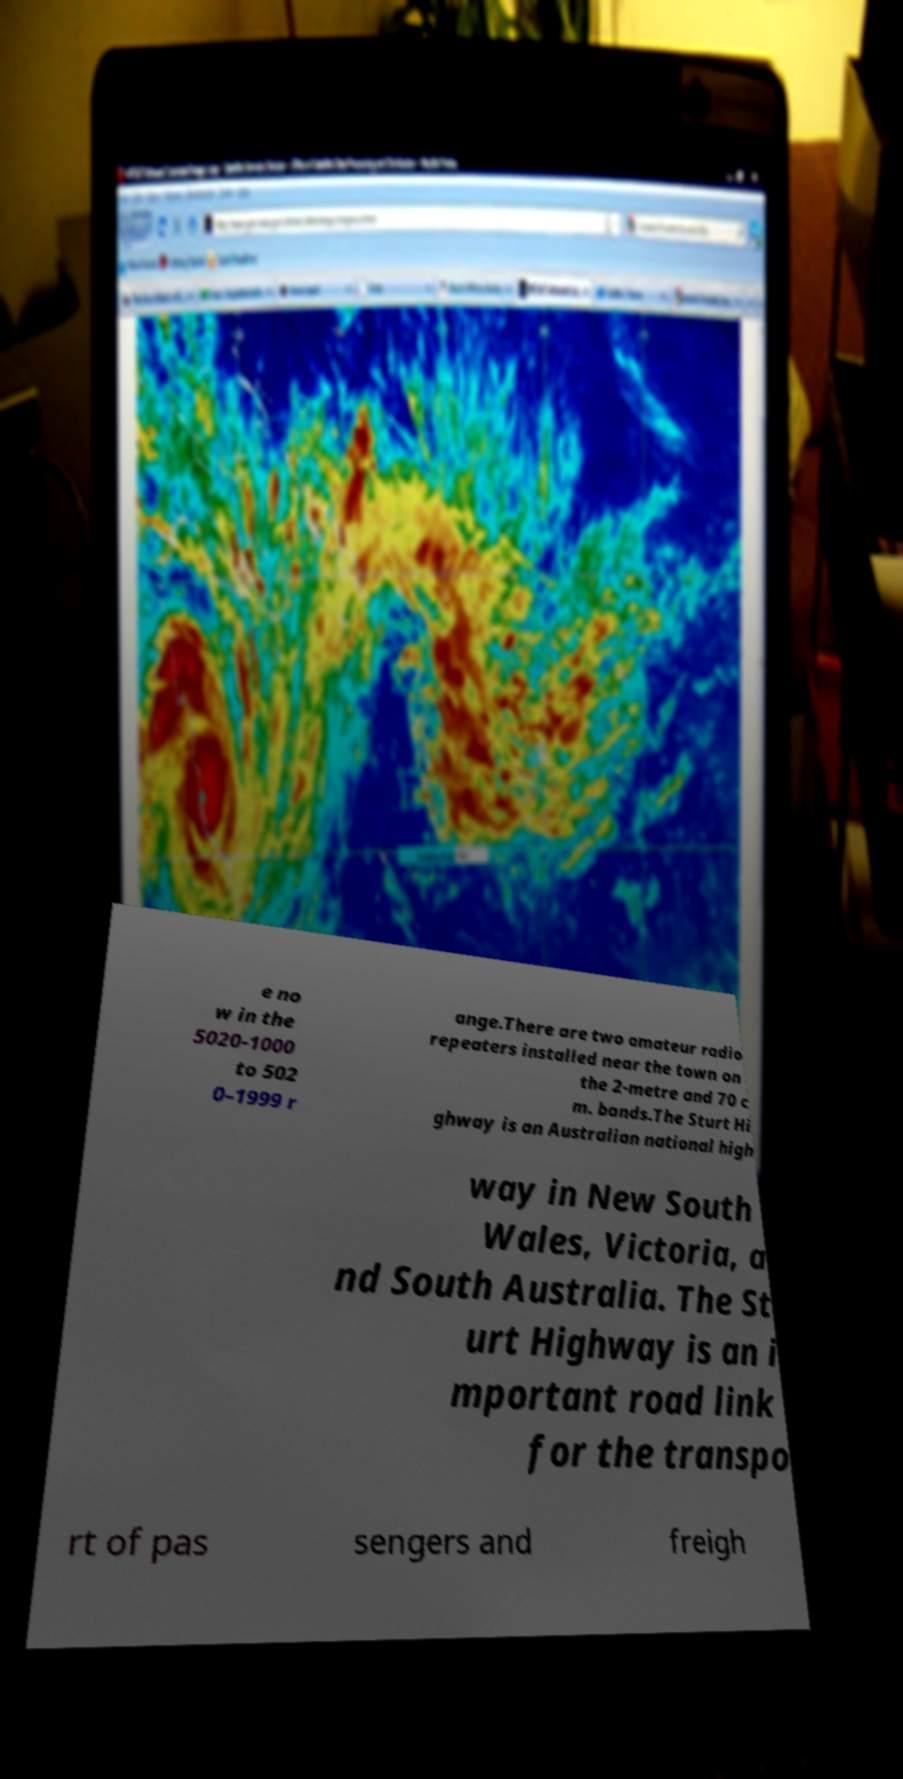Could you extract and type out the text from this image? e no w in the 5020-1000 to 502 0–1999 r ange.There are two amateur radio repeaters installed near the town on the 2-metre and 70 c m. bands.The Sturt Hi ghway is an Australian national high way in New South Wales, Victoria, a nd South Australia. The St urt Highway is an i mportant road link for the transpo rt of pas sengers and freigh 